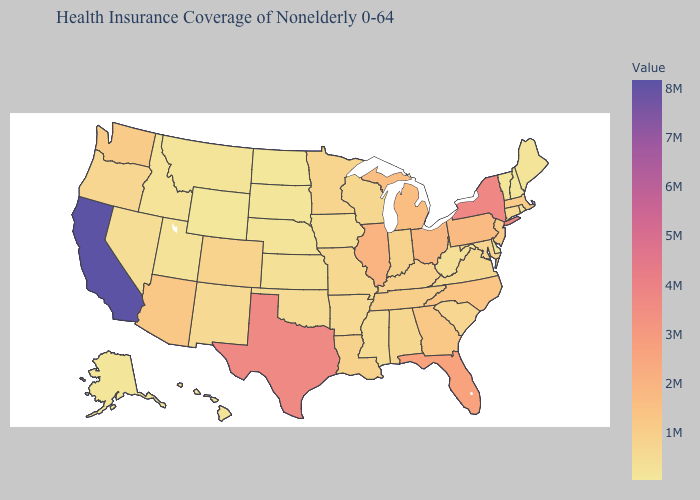Is the legend a continuous bar?
Keep it brief. Yes. Which states have the highest value in the USA?
Short answer required. California. Among the states that border Montana , does Idaho have the highest value?
Give a very brief answer. Yes. Which states have the highest value in the USA?
Write a very short answer. California. Does Pennsylvania have a higher value than West Virginia?
Give a very brief answer. Yes. Among the states that border Illinois , which have the lowest value?
Give a very brief answer. Iowa. 